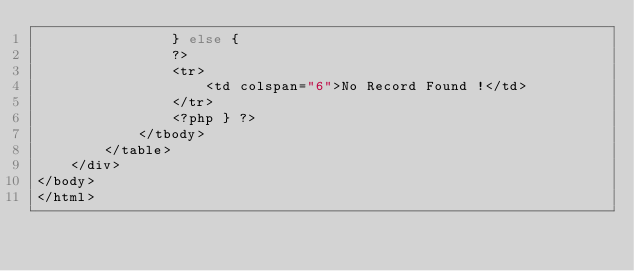<code> <loc_0><loc_0><loc_500><loc_500><_PHP_>                } else {           
                ?>
                <tr>
                    <td colspan="6">No Record Found !</td>
                </tr>
                <?php } ?>
            </tbody>
        </table>
    </div>
</body>
</html>


</code> 